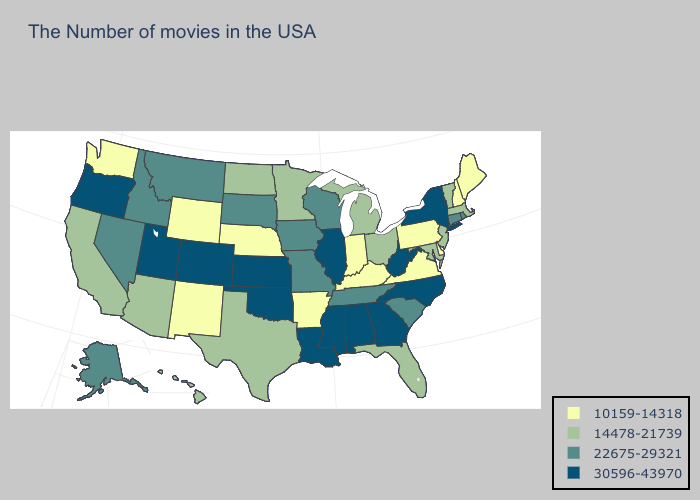What is the lowest value in the USA?
Concise answer only. 10159-14318. Among the states that border California , does Oregon have the lowest value?
Answer briefly. No. Which states have the lowest value in the USA?
Short answer required. Maine, New Hampshire, Delaware, Pennsylvania, Virginia, Kentucky, Indiana, Arkansas, Nebraska, Wyoming, New Mexico, Washington. Among the states that border Louisiana , which have the highest value?
Concise answer only. Mississippi. Name the states that have a value in the range 22675-29321?
Give a very brief answer. Rhode Island, Connecticut, South Carolina, Tennessee, Wisconsin, Missouri, Iowa, South Dakota, Montana, Idaho, Nevada, Alaska. Does Washington have the same value as Iowa?
Answer briefly. No. Does California have the highest value in the West?
Be succinct. No. What is the value of Michigan?
Be succinct. 14478-21739. What is the highest value in the Northeast ?
Be succinct. 30596-43970. Name the states that have a value in the range 30596-43970?
Short answer required. New York, North Carolina, West Virginia, Georgia, Alabama, Illinois, Mississippi, Louisiana, Kansas, Oklahoma, Colorado, Utah, Oregon. What is the value of Washington?
Short answer required. 10159-14318. Among the states that border Nebraska , does South Dakota have the lowest value?
Quick response, please. No. Among the states that border Pennsylvania , which have the lowest value?
Quick response, please. Delaware. Name the states that have a value in the range 30596-43970?
Short answer required. New York, North Carolina, West Virginia, Georgia, Alabama, Illinois, Mississippi, Louisiana, Kansas, Oklahoma, Colorado, Utah, Oregon. 